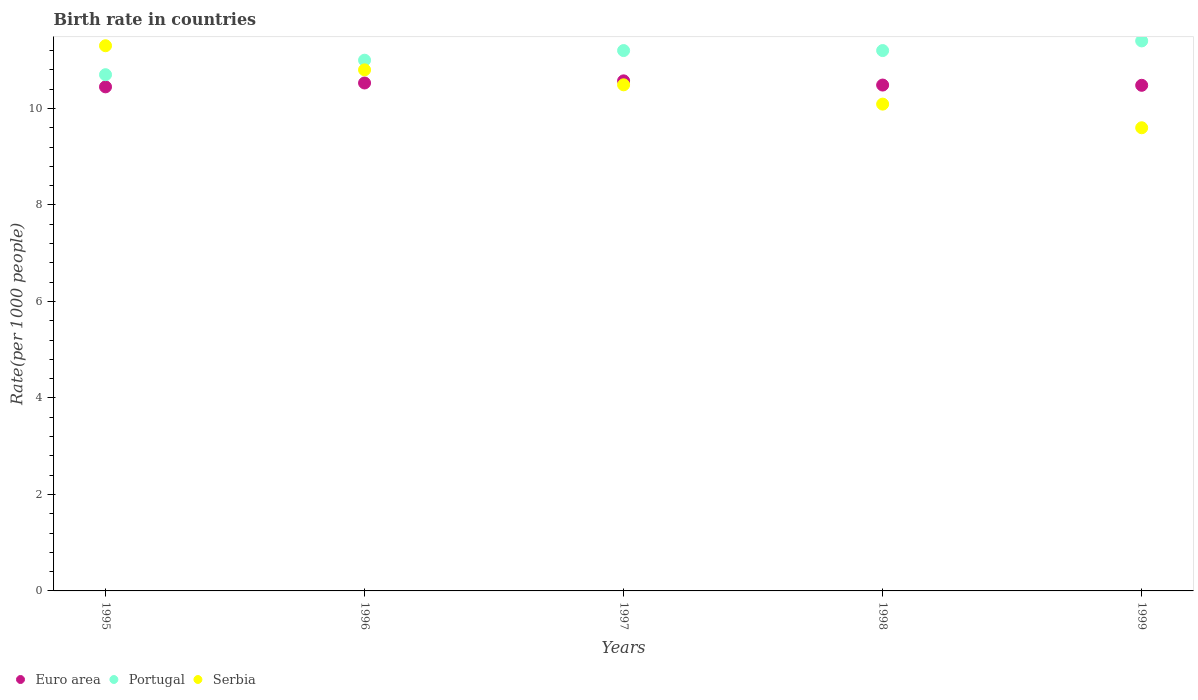How many different coloured dotlines are there?
Give a very brief answer. 3. Is the number of dotlines equal to the number of legend labels?
Your response must be concise. Yes. What is the birth rate in Serbia in 1995?
Keep it short and to the point. 11.3. In which year was the birth rate in Portugal maximum?
Your answer should be compact. 1999. What is the total birth rate in Serbia in the graph?
Offer a very short reply. 52.28. What is the difference between the birth rate in Euro area in 1996 and that in 1997?
Make the answer very short. -0.04. What is the difference between the birth rate in Euro area in 1995 and the birth rate in Portugal in 1999?
Offer a very short reply. -0.95. What is the average birth rate in Portugal per year?
Ensure brevity in your answer.  11.1. In the year 1996, what is the difference between the birth rate in Portugal and birth rate in Serbia?
Ensure brevity in your answer.  0.2. In how many years, is the birth rate in Portugal greater than 4?
Give a very brief answer. 5. What is the ratio of the birth rate in Serbia in 1997 to that in 1998?
Ensure brevity in your answer.  1.04. Is the difference between the birth rate in Portugal in 1998 and 1999 greater than the difference between the birth rate in Serbia in 1998 and 1999?
Make the answer very short. No. What is the difference between the highest and the second highest birth rate in Euro area?
Keep it short and to the point. 0.04. What is the difference between the highest and the lowest birth rate in Euro area?
Offer a very short reply. 0.12. In how many years, is the birth rate in Euro area greater than the average birth rate in Euro area taken over all years?
Make the answer very short. 2. Does the birth rate in Euro area monotonically increase over the years?
Offer a terse response. No. Is the birth rate in Serbia strictly less than the birth rate in Euro area over the years?
Make the answer very short. No. How many years are there in the graph?
Provide a short and direct response. 5. Are the values on the major ticks of Y-axis written in scientific E-notation?
Your answer should be compact. No. Does the graph contain any zero values?
Your response must be concise. No. How many legend labels are there?
Give a very brief answer. 3. How are the legend labels stacked?
Your response must be concise. Horizontal. What is the title of the graph?
Ensure brevity in your answer.  Birth rate in countries. What is the label or title of the Y-axis?
Your response must be concise. Rate(per 1000 people). What is the Rate(per 1000 people) of Euro area in 1995?
Make the answer very short. 10.45. What is the Rate(per 1000 people) in Euro area in 1996?
Offer a very short reply. 10.53. What is the Rate(per 1000 people) in Serbia in 1996?
Offer a very short reply. 10.8. What is the Rate(per 1000 people) of Euro area in 1997?
Give a very brief answer. 10.57. What is the Rate(per 1000 people) in Portugal in 1997?
Your answer should be very brief. 11.2. What is the Rate(per 1000 people) in Serbia in 1997?
Ensure brevity in your answer.  10.49. What is the Rate(per 1000 people) in Euro area in 1998?
Ensure brevity in your answer.  10.49. What is the Rate(per 1000 people) of Portugal in 1998?
Provide a succinct answer. 11.2. What is the Rate(per 1000 people) in Serbia in 1998?
Offer a very short reply. 10.09. What is the Rate(per 1000 people) in Euro area in 1999?
Make the answer very short. 10.48. Across all years, what is the maximum Rate(per 1000 people) in Euro area?
Keep it short and to the point. 10.57. Across all years, what is the minimum Rate(per 1000 people) in Euro area?
Provide a short and direct response. 10.45. What is the total Rate(per 1000 people) in Euro area in the graph?
Your response must be concise. 52.51. What is the total Rate(per 1000 people) in Portugal in the graph?
Give a very brief answer. 55.5. What is the total Rate(per 1000 people) of Serbia in the graph?
Make the answer very short. 52.28. What is the difference between the Rate(per 1000 people) of Euro area in 1995 and that in 1996?
Give a very brief answer. -0.08. What is the difference between the Rate(per 1000 people) in Portugal in 1995 and that in 1996?
Your answer should be very brief. -0.3. What is the difference between the Rate(per 1000 people) in Serbia in 1995 and that in 1996?
Provide a short and direct response. 0.5. What is the difference between the Rate(per 1000 people) of Euro area in 1995 and that in 1997?
Your answer should be very brief. -0.12. What is the difference between the Rate(per 1000 people) in Serbia in 1995 and that in 1997?
Your response must be concise. 0.81. What is the difference between the Rate(per 1000 people) in Euro area in 1995 and that in 1998?
Give a very brief answer. -0.04. What is the difference between the Rate(per 1000 people) in Portugal in 1995 and that in 1998?
Offer a very short reply. -0.5. What is the difference between the Rate(per 1000 people) of Serbia in 1995 and that in 1998?
Provide a succinct answer. 1.21. What is the difference between the Rate(per 1000 people) in Euro area in 1995 and that in 1999?
Offer a terse response. -0.03. What is the difference between the Rate(per 1000 people) in Portugal in 1995 and that in 1999?
Offer a very short reply. -0.7. What is the difference between the Rate(per 1000 people) in Serbia in 1995 and that in 1999?
Your answer should be very brief. 1.7. What is the difference between the Rate(per 1000 people) in Euro area in 1996 and that in 1997?
Provide a short and direct response. -0.04. What is the difference between the Rate(per 1000 people) of Serbia in 1996 and that in 1997?
Give a very brief answer. 0.31. What is the difference between the Rate(per 1000 people) in Euro area in 1996 and that in 1998?
Ensure brevity in your answer.  0.04. What is the difference between the Rate(per 1000 people) of Serbia in 1996 and that in 1998?
Offer a terse response. 0.71. What is the difference between the Rate(per 1000 people) of Euro area in 1996 and that in 1999?
Offer a very short reply. 0.05. What is the difference between the Rate(per 1000 people) in Euro area in 1997 and that in 1998?
Your answer should be compact. 0.09. What is the difference between the Rate(per 1000 people) of Portugal in 1997 and that in 1998?
Offer a very short reply. 0. What is the difference between the Rate(per 1000 people) in Serbia in 1997 and that in 1998?
Provide a short and direct response. 0.4. What is the difference between the Rate(per 1000 people) of Euro area in 1997 and that in 1999?
Your response must be concise. 0.09. What is the difference between the Rate(per 1000 people) of Serbia in 1997 and that in 1999?
Provide a short and direct response. 0.89. What is the difference between the Rate(per 1000 people) in Euro area in 1998 and that in 1999?
Make the answer very short. 0.01. What is the difference between the Rate(per 1000 people) in Portugal in 1998 and that in 1999?
Provide a succinct answer. -0.2. What is the difference between the Rate(per 1000 people) in Serbia in 1998 and that in 1999?
Give a very brief answer. 0.49. What is the difference between the Rate(per 1000 people) of Euro area in 1995 and the Rate(per 1000 people) of Portugal in 1996?
Offer a terse response. -0.55. What is the difference between the Rate(per 1000 people) in Euro area in 1995 and the Rate(per 1000 people) in Serbia in 1996?
Offer a terse response. -0.35. What is the difference between the Rate(per 1000 people) in Euro area in 1995 and the Rate(per 1000 people) in Portugal in 1997?
Provide a succinct answer. -0.75. What is the difference between the Rate(per 1000 people) in Euro area in 1995 and the Rate(per 1000 people) in Serbia in 1997?
Provide a short and direct response. -0.04. What is the difference between the Rate(per 1000 people) of Portugal in 1995 and the Rate(per 1000 people) of Serbia in 1997?
Your answer should be compact. 0.21. What is the difference between the Rate(per 1000 people) of Euro area in 1995 and the Rate(per 1000 people) of Portugal in 1998?
Offer a terse response. -0.75. What is the difference between the Rate(per 1000 people) in Euro area in 1995 and the Rate(per 1000 people) in Serbia in 1998?
Your answer should be very brief. 0.36. What is the difference between the Rate(per 1000 people) in Portugal in 1995 and the Rate(per 1000 people) in Serbia in 1998?
Make the answer very short. 0.61. What is the difference between the Rate(per 1000 people) of Euro area in 1995 and the Rate(per 1000 people) of Portugal in 1999?
Keep it short and to the point. -0.95. What is the difference between the Rate(per 1000 people) of Euro area in 1995 and the Rate(per 1000 people) of Serbia in 1999?
Offer a terse response. 0.85. What is the difference between the Rate(per 1000 people) of Euro area in 1996 and the Rate(per 1000 people) of Portugal in 1997?
Offer a very short reply. -0.67. What is the difference between the Rate(per 1000 people) in Euro area in 1996 and the Rate(per 1000 people) in Serbia in 1997?
Give a very brief answer. 0.04. What is the difference between the Rate(per 1000 people) in Portugal in 1996 and the Rate(per 1000 people) in Serbia in 1997?
Provide a succinct answer. 0.51. What is the difference between the Rate(per 1000 people) in Euro area in 1996 and the Rate(per 1000 people) in Portugal in 1998?
Offer a terse response. -0.67. What is the difference between the Rate(per 1000 people) of Euro area in 1996 and the Rate(per 1000 people) of Serbia in 1998?
Provide a succinct answer. 0.44. What is the difference between the Rate(per 1000 people) of Portugal in 1996 and the Rate(per 1000 people) of Serbia in 1998?
Make the answer very short. 0.91. What is the difference between the Rate(per 1000 people) of Euro area in 1996 and the Rate(per 1000 people) of Portugal in 1999?
Provide a short and direct response. -0.87. What is the difference between the Rate(per 1000 people) in Euro area in 1996 and the Rate(per 1000 people) in Serbia in 1999?
Offer a terse response. 0.93. What is the difference between the Rate(per 1000 people) of Euro area in 1997 and the Rate(per 1000 people) of Portugal in 1998?
Your answer should be compact. -0.63. What is the difference between the Rate(per 1000 people) of Euro area in 1997 and the Rate(per 1000 people) of Serbia in 1998?
Make the answer very short. 0.48. What is the difference between the Rate(per 1000 people) of Portugal in 1997 and the Rate(per 1000 people) of Serbia in 1998?
Your answer should be compact. 1.11. What is the difference between the Rate(per 1000 people) of Euro area in 1997 and the Rate(per 1000 people) of Portugal in 1999?
Your answer should be very brief. -0.83. What is the difference between the Rate(per 1000 people) of Euro area in 1997 and the Rate(per 1000 people) of Serbia in 1999?
Ensure brevity in your answer.  0.97. What is the difference between the Rate(per 1000 people) of Euro area in 1998 and the Rate(per 1000 people) of Portugal in 1999?
Your response must be concise. -0.91. What is the difference between the Rate(per 1000 people) in Euro area in 1998 and the Rate(per 1000 people) in Serbia in 1999?
Offer a terse response. 0.89. What is the difference between the Rate(per 1000 people) of Portugal in 1998 and the Rate(per 1000 people) of Serbia in 1999?
Keep it short and to the point. 1.6. What is the average Rate(per 1000 people) of Euro area per year?
Your answer should be compact. 10.5. What is the average Rate(per 1000 people) in Portugal per year?
Provide a short and direct response. 11.1. What is the average Rate(per 1000 people) of Serbia per year?
Your answer should be very brief. 10.46. In the year 1995, what is the difference between the Rate(per 1000 people) of Euro area and Rate(per 1000 people) of Portugal?
Make the answer very short. -0.25. In the year 1995, what is the difference between the Rate(per 1000 people) in Euro area and Rate(per 1000 people) in Serbia?
Your answer should be very brief. -0.85. In the year 1996, what is the difference between the Rate(per 1000 people) of Euro area and Rate(per 1000 people) of Portugal?
Provide a short and direct response. -0.47. In the year 1996, what is the difference between the Rate(per 1000 people) in Euro area and Rate(per 1000 people) in Serbia?
Offer a very short reply. -0.27. In the year 1997, what is the difference between the Rate(per 1000 people) in Euro area and Rate(per 1000 people) in Portugal?
Keep it short and to the point. -0.63. In the year 1997, what is the difference between the Rate(per 1000 people) of Euro area and Rate(per 1000 people) of Serbia?
Offer a very short reply. 0.08. In the year 1997, what is the difference between the Rate(per 1000 people) of Portugal and Rate(per 1000 people) of Serbia?
Keep it short and to the point. 0.71. In the year 1998, what is the difference between the Rate(per 1000 people) in Euro area and Rate(per 1000 people) in Portugal?
Provide a succinct answer. -0.71. In the year 1998, what is the difference between the Rate(per 1000 people) of Euro area and Rate(per 1000 people) of Serbia?
Provide a short and direct response. 0.4. In the year 1998, what is the difference between the Rate(per 1000 people) of Portugal and Rate(per 1000 people) of Serbia?
Provide a succinct answer. 1.11. In the year 1999, what is the difference between the Rate(per 1000 people) of Euro area and Rate(per 1000 people) of Portugal?
Your answer should be compact. -0.92. In the year 1999, what is the difference between the Rate(per 1000 people) in Euro area and Rate(per 1000 people) in Serbia?
Your answer should be very brief. 0.88. What is the ratio of the Rate(per 1000 people) of Portugal in 1995 to that in 1996?
Keep it short and to the point. 0.97. What is the ratio of the Rate(per 1000 people) of Serbia in 1995 to that in 1996?
Offer a terse response. 1.05. What is the ratio of the Rate(per 1000 people) in Euro area in 1995 to that in 1997?
Keep it short and to the point. 0.99. What is the ratio of the Rate(per 1000 people) of Portugal in 1995 to that in 1997?
Offer a terse response. 0.96. What is the ratio of the Rate(per 1000 people) in Serbia in 1995 to that in 1997?
Make the answer very short. 1.08. What is the ratio of the Rate(per 1000 people) of Portugal in 1995 to that in 1998?
Make the answer very short. 0.96. What is the ratio of the Rate(per 1000 people) of Serbia in 1995 to that in 1998?
Provide a succinct answer. 1.12. What is the ratio of the Rate(per 1000 people) of Portugal in 1995 to that in 1999?
Your answer should be very brief. 0.94. What is the ratio of the Rate(per 1000 people) in Serbia in 1995 to that in 1999?
Your answer should be compact. 1.18. What is the ratio of the Rate(per 1000 people) of Euro area in 1996 to that in 1997?
Offer a very short reply. 1. What is the ratio of the Rate(per 1000 people) of Portugal in 1996 to that in 1997?
Your answer should be very brief. 0.98. What is the ratio of the Rate(per 1000 people) in Serbia in 1996 to that in 1997?
Make the answer very short. 1.03. What is the ratio of the Rate(per 1000 people) of Portugal in 1996 to that in 1998?
Your response must be concise. 0.98. What is the ratio of the Rate(per 1000 people) in Serbia in 1996 to that in 1998?
Make the answer very short. 1.07. What is the ratio of the Rate(per 1000 people) of Euro area in 1996 to that in 1999?
Provide a short and direct response. 1. What is the ratio of the Rate(per 1000 people) in Portugal in 1996 to that in 1999?
Your answer should be compact. 0.96. What is the ratio of the Rate(per 1000 people) of Serbia in 1996 to that in 1999?
Your answer should be compact. 1.12. What is the ratio of the Rate(per 1000 people) of Euro area in 1997 to that in 1998?
Offer a terse response. 1.01. What is the ratio of the Rate(per 1000 people) of Portugal in 1997 to that in 1998?
Offer a very short reply. 1. What is the ratio of the Rate(per 1000 people) of Serbia in 1997 to that in 1998?
Your response must be concise. 1.04. What is the ratio of the Rate(per 1000 people) in Euro area in 1997 to that in 1999?
Give a very brief answer. 1.01. What is the ratio of the Rate(per 1000 people) in Portugal in 1997 to that in 1999?
Make the answer very short. 0.98. What is the ratio of the Rate(per 1000 people) in Serbia in 1997 to that in 1999?
Give a very brief answer. 1.09. What is the ratio of the Rate(per 1000 people) in Euro area in 1998 to that in 1999?
Provide a succinct answer. 1. What is the ratio of the Rate(per 1000 people) of Portugal in 1998 to that in 1999?
Keep it short and to the point. 0.98. What is the ratio of the Rate(per 1000 people) in Serbia in 1998 to that in 1999?
Your answer should be very brief. 1.05. What is the difference between the highest and the second highest Rate(per 1000 people) in Euro area?
Give a very brief answer. 0.04. What is the difference between the highest and the second highest Rate(per 1000 people) in Portugal?
Your answer should be compact. 0.2. What is the difference between the highest and the second highest Rate(per 1000 people) in Serbia?
Offer a terse response. 0.5. What is the difference between the highest and the lowest Rate(per 1000 people) in Euro area?
Provide a short and direct response. 0.12. What is the difference between the highest and the lowest Rate(per 1000 people) of Portugal?
Give a very brief answer. 0.7. What is the difference between the highest and the lowest Rate(per 1000 people) in Serbia?
Your response must be concise. 1.7. 